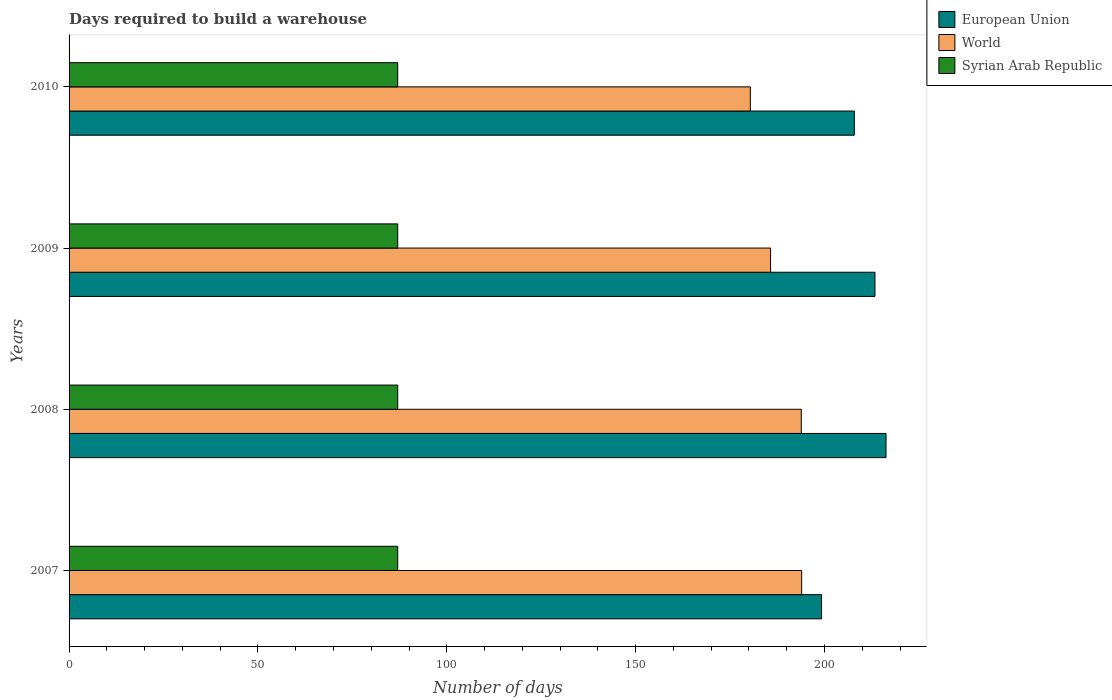How many different coloured bars are there?
Keep it short and to the point. 3. How many groups of bars are there?
Offer a very short reply. 4. Are the number of bars per tick equal to the number of legend labels?
Offer a terse response. Yes. Are the number of bars on each tick of the Y-axis equal?
Provide a succinct answer. Yes. How many bars are there on the 3rd tick from the top?
Ensure brevity in your answer.  3. What is the label of the 2nd group of bars from the top?
Your response must be concise. 2009. What is the days required to build a warehouse in in European Union in 2007?
Provide a succinct answer. 199.21. Across all years, what is the maximum days required to build a warehouse in in European Union?
Provide a succinct answer. 216.28. Across all years, what is the minimum days required to build a warehouse in in World?
Make the answer very short. 180.35. In which year was the days required to build a warehouse in in European Union maximum?
Make the answer very short. 2008. What is the total days required to build a warehouse in in Syrian Arab Republic in the graph?
Make the answer very short. 348. What is the difference between the days required to build a warehouse in in European Union in 2009 and the days required to build a warehouse in in World in 2007?
Your response must be concise. 19.4. What is the average days required to build a warehouse in in European Union per year?
Provide a short and direct response. 209.18. In the year 2008, what is the difference between the days required to build a warehouse in in World and days required to build a warehouse in in Syrian Arab Republic?
Provide a short and direct response. 106.84. What is the ratio of the days required to build a warehouse in in World in 2009 to that in 2010?
Your answer should be compact. 1.03. Is the days required to build a warehouse in in Syrian Arab Republic in 2007 less than that in 2008?
Make the answer very short. No. Is the difference between the days required to build a warehouse in in World in 2008 and 2009 greater than the difference between the days required to build a warehouse in in Syrian Arab Republic in 2008 and 2009?
Keep it short and to the point. Yes. What is the difference between the highest and the second highest days required to build a warehouse in in World?
Provide a short and direct response. 0.11. What is the difference between the highest and the lowest days required to build a warehouse in in World?
Your answer should be very brief. 13.6. What does the 3rd bar from the top in 2007 represents?
Offer a terse response. European Union. What does the 3rd bar from the bottom in 2009 represents?
Ensure brevity in your answer.  Syrian Arab Republic. How many years are there in the graph?
Your answer should be compact. 4. What is the difference between two consecutive major ticks on the X-axis?
Give a very brief answer. 50. Does the graph contain any zero values?
Your answer should be very brief. No. How are the legend labels stacked?
Keep it short and to the point. Vertical. What is the title of the graph?
Provide a succinct answer. Days required to build a warehouse. Does "United Kingdom" appear as one of the legend labels in the graph?
Your answer should be very brief. No. What is the label or title of the X-axis?
Offer a terse response. Number of days. What is the Number of days in European Union in 2007?
Provide a succinct answer. 199.21. What is the Number of days in World in 2007?
Your response must be concise. 193.95. What is the Number of days in Syrian Arab Republic in 2007?
Ensure brevity in your answer.  87. What is the Number of days in European Union in 2008?
Offer a very short reply. 216.28. What is the Number of days in World in 2008?
Your answer should be compact. 193.84. What is the Number of days in European Union in 2009?
Your response must be concise. 213.35. What is the Number of days in World in 2009?
Ensure brevity in your answer.  185.71. What is the Number of days of European Union in 2010?
Offer a very short reply. 207.89. What is the Number of days of World in 2010?
Your answer should be compact. 180.35. Across all years, what is the maximum Number of days in European Union?
Your answer should be very brief. 216.28. Across all years, what is the maximum Number of days in World?
Provide a succinct answer. 193.95. Across all years, what is the minimum Number of days of European Union?
Keep it short and to the point. 199.21. Across all years, what is the minimum Number of days in World?
Give a very brief answer. 180.35. What is the total Number of days in European Union in the graph?
Provide a succinct answer. 836.73. What is the total Number of days of World in the graph?
Ensure brevity in your answer.  753.86. What is the total Number of days in Syrian Arab Republic in the graph?
Offer a terse response. 348. What is the difference between the Number of days of European Union in 2007 and that in 2008?
Your answer should be very brief. -17.07. What is the difference between the Number of days of World in 2007 and that in 2008?
Keep it short and to the point. 0.11. What is the difference between the Number of days in European Union in 2007 and that in 2009?
Give a very brief answer. -14.14. What is the difference between the Number of days in World in 2007 and that in 2009?
Give a very brief answer. 8.24. What is the difference between the Number of days of European Union in 2007 and that in 2010?
Provide a short and direct response. -8.68. What is the difference between the Number of days in World in 2007 and that in 2010?
Ensure brevity in your answer.  13.6. What is the difference between the Number of days in Syrian Arab Republic in 2007 and that in 2010?
Keep it short and to the point. 0. What is the difference between the Number of days of European Union in 2008 and that in 2009?
Your response must be concise. 2.93. What is the difference between the Number of days in World in 2008 and that in 2009?
Provide a short and direct response. 8.13. What is the difference between the Number of days in European Union in 2008 and that in 2010?
Your answer should be very brief. 8.39. What is the difference between the Number of days in World in 2008 and that in 2010?
Your response must be concise. 13.49. What is the difference between the Number of days in Syrian Arab Republic in 2008 and that in 2010?
Provide a succinct answer. 0. What is the difference between the Number of days in European Union in 2009 and that in 2010?
Keep it short and to the point. 5.46. What is the difference between the Number of days of World in 2009 and that in 2010?
Offer a terse response. 5.36. What is the difference between the Number of days of Syrian Arab Republic in 2009 and that in 2010?
Your answer should be very brief. 0. What is the difference between the Number of days in European Union in 2007 and the Number of days in World in 2008?
Give a very brief answer. 5.37. What is the difference between the Number of days of European Union in 2007 and the Number of days of Syrian Arab Republic in 2008?
Keep it short and to the point. 112.21. What is the difference between the Number of days of World in 2007 and the Number of days of Syrian Arab Republic in 2008?
Keep it short and to the point. 106.95. What is the difference between the Number of days of European Union in 2007 and the Number of days of World in 2009?
Offer a very short reply. 13.5. What is the difference between the Number of days of European Union in 2007 and the Number of days of Syrian Arab Republic in 2009?
Your answer should be compact. 112.21. What is the difference between the Number of days of World in 2007 and the Number of days of Syrian Arab Republic in 2009?
Provide a succinct answer. 106.95. What is the difference between the Number of days of European Union in 2007 and the Number of days of World in 2010?
Provide a succinct answer. 18.86. What is the difference between the Number of days in European Union in 2007 and the Number of days in Syrian Arab Republic in 2010?
Make the answer very short. 112.21. What is the difference between the Number of days in World in 2007 and the Number of days in Syrian Arab Republic in 2010?
Your answer should be compact. 106.95. What is the difference between the Number of days in European Union in 2008 and the Number of days in World in 2009?
Provide a short and direct response. 30.56. What is the difference between the Number of days in European Union in 2008 and the Number of days in Syrian Arab Republic in 2009?
Keep it short and to the point. 129.28. What is the difference between the Number of days of World in 2008 and the Number of days of Syrian Arab Republic in 2009?
Your answer should be very brief. 106.84. What is the difference between the Number of days of European Union in 2008 and the Number of days of World in 2010?
Offer a very short reply. 35.92. What is the difference between the Number of days in European Union in 2008 and the Number of days in Syrian Arab Republic in 2010?
Your answer should be very brief. 129.28. What is the difference between the Number of days of World in 2008 and the Number of days of Syrian Arab Republic in 2010?
Offer a terse response. 106.84. What is the difference between the Number of days in European Union in 2009 and the Number of days in World in 2010?
Make the answer very short. 33. What is the difference between the Number of days of European Union in 2009 and the Number of days of Syrian Arab Republic in 2010?
Offer a terse response. 126.35. What is the difference between the Number of days of World in 2009 and the Number of days of Syrian Arab Republic in 2010?
Offer a very short reply. 98.71. What is the average Number of days of European Union per year?
Offer a very short reply. 209.18. What is the average Number of days in World per year?
Your response must be concise. 188.47. In the year 2007, what is the difference between the Number of days in European Union and Number of days in World?
Your response must be concise. 5.26. In the year 2007, what is the difference between the Number of days in European Union and Number of days in Syrian Arab Republic?
Your answer should be compact. 112.21. In the year 2007, what is the difference between the Number of days of World and Number of days of Syrian Arab Republic?
Provide a short and direct response. 106.95. In the year 2008, what is the difference between the Number of days in European Union and Number of days in World?
Offer a terse response. 22.43. In the year 2008, what is the difference between the Number of days of European Union and Number of days of Syrian Arab Republic?
Keep it short and to the point. 129.28. In the year 2008, what is the difference between the Number of days in World and Number of days in Syrian Arab Republic?
Your answer should be very brief. 106.84. In the year 2009, what is the difference between the Number of days in European Union and Number of days in World?
Make the answer very short. 27.64. In the year 2009, what is the difference between the Number of days in European Union and Number of days in Syrian Arab Republic?
Keep it short and to the point. 126.35. In the year 2009, what is the difference between the Number of days in World and Number of days in Syrian Arab Republic?
Ensure brevity in your answer.  98.71. In the year 2010, what is the difference between the Number of days of European Union and Number of days of World?
Make the answer very short. 27.54. In the year 2010, what is the difference between the Number of days of European Union and Number of days of Syrian Arab Republic?
Make the answer very short. 120.89. In the year 2010, what is the difference between the Number of days in World and Number of days in Syrian Arab Republic?
Your answer should be compact. 93.35. What is the ratio of the Number of days in European Union in 2007 to that in 2008?
Make the answer very short. 0.92. What is the ratio of the Number of days in World in 2007 to that in 2008?
Make the answer very short. 1. What is the ratio of the Number of days of European Union in 2007 to that in 2009?
Give a very brief answer. 0.93. What is the ratio of the Number of days in World in 2007 to that in 2009?
Offer a very short reply. 1.04. What is the ratio of the Number of days of European Union in 2007 to that in 2010?
Provide a short and direct response. 0.96. What is the ratio of the Number of days in World in 2007 to that in 2010?
Your answer should be compact. 1.08. What is the ratio of the Number of days of Syrian Arab Republic in 2007 to that in 2010?
Ensure brevity in your answer.  1. What is the ratio of the Number of days of European Union in 2008 to that in 2009?
Give a very brief answer. 1.01. What is the ratio of the Number of days in World in 2008 to that in 2009?
Provide a short and direct response. 1.04. What is the ratio of the Number of days of Syrian Arab Republic in 2008 to that in 2009?
Offer a very short reply. 1. What is the ratio of the Number of days in European Union in 2008 to that in 2010?
Ensure brevity in your answer.  1.04. What is the ratio of the Number of days of World in 2008 to that in 2010?
Provide a succinct answer. 1.07. What is the ratio of the Number of days in Syrian Arab Republic in 2008 to that in 2010?
Your answer should be very brief. 1. What is the ratio of the Number of days of European Union in 2009 to that in 2010?
Your response must be concise. 1.03. What is the ratio of the Number of days of World in 2009 to that in 2010?
Give a very brief answer. 1.03. What is the difference between the highest and the second highest Number of days in European Union?
Your answer should be very brief. 2.93. What is the difference between the highest and the second highest Number of days of World?
Your response must be concise. 0.11. What is the difference between the highest and the lowest Number of days of European Union?
Ensure brevity in your answer.  17.07. What is the difference between the highest and the lowest Number of days in World?
Keep it short and to the point. 13.6. What is the difference between the highest and the lowest Number of days in Syrian Arab Republic?
Offer a terse response. 0. 